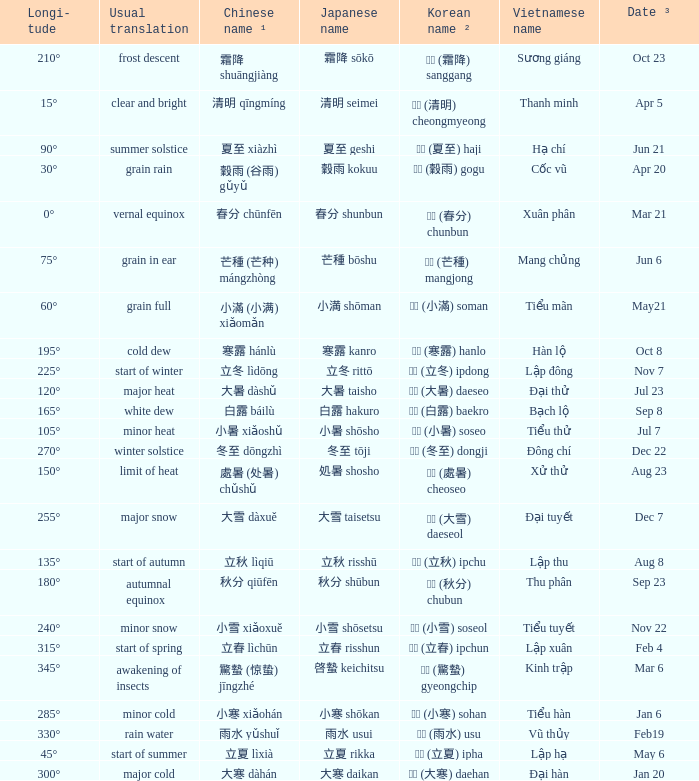Which Longi- tude is on jun 6? 75°. 